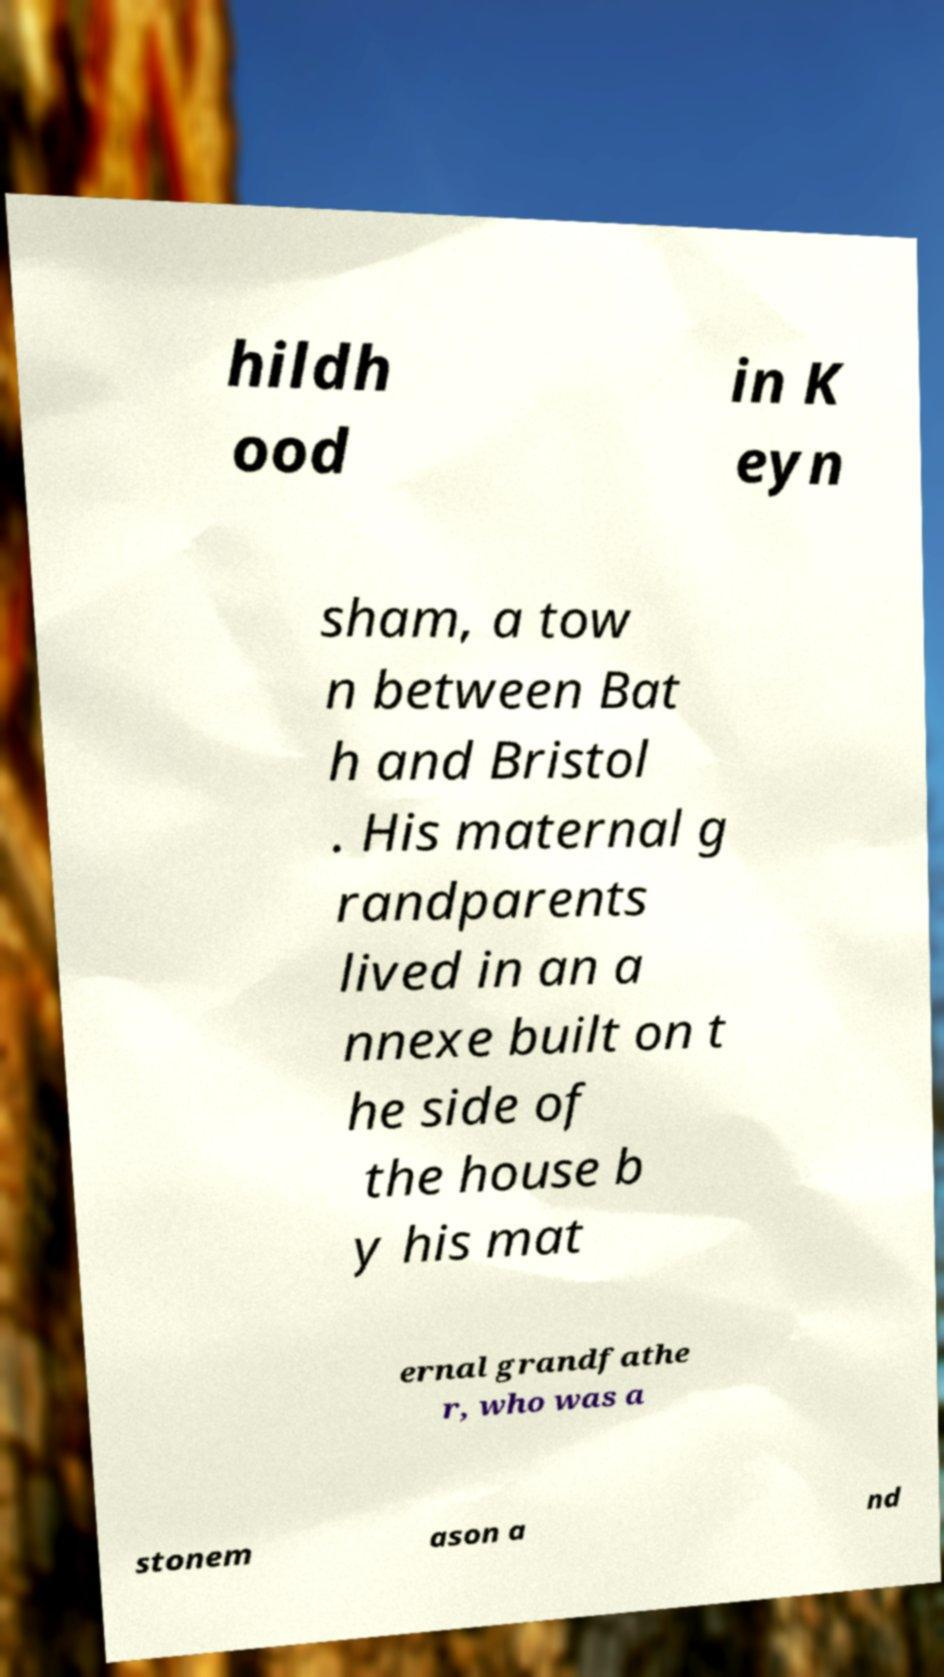Could you assist in decoding the text presented in this image and type it out clearly? hildh ood in K eyn sham, a tow n between Bat h and Bristol . His maternal g randparents lived in an a nnexe built on t he side of the house b y his mat ernal grandfathe r, who was a stonem ason a nd 